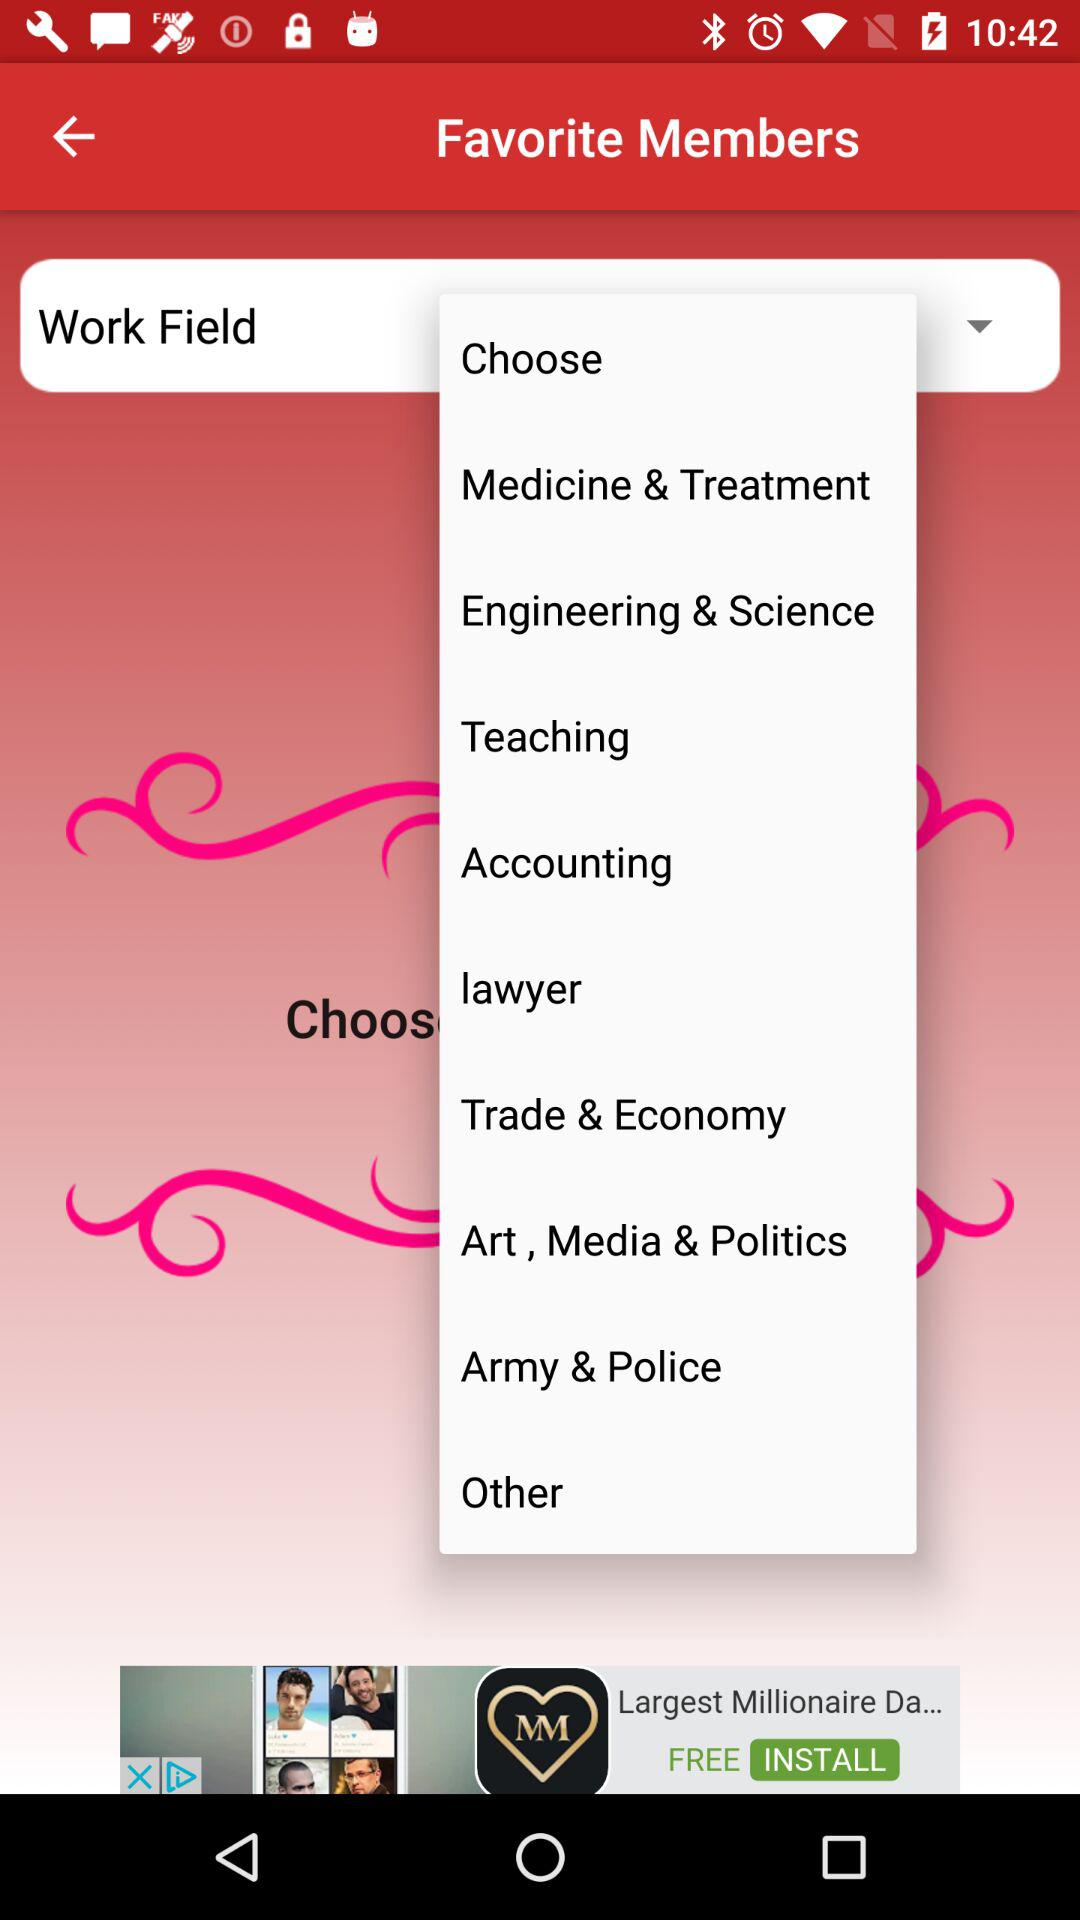What are the different options in "Work Field"? The different options in "Work Field" are "Medicine & Treatment", "Engineering & Science", "Teaching", "Accounting", "lawyer", "Trade & Economy", "Art, Media & Politics", "Army & Police" and "Other". 